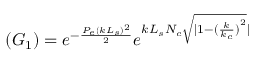Convert formula to latex. <formula><loc_0><loc_0><loc_500><loc_500>( G _ { 1 } ) = e ^ { - \frac { P _ { e } ( k L _ { s } ) ^ { 2 } } { 2 } } e ^ { k L _ { s } N _ { c } \sqrt { | 1 - { ( \frac { k } { k _ { c } } ) } ^ { 2 } } | }</formula> 